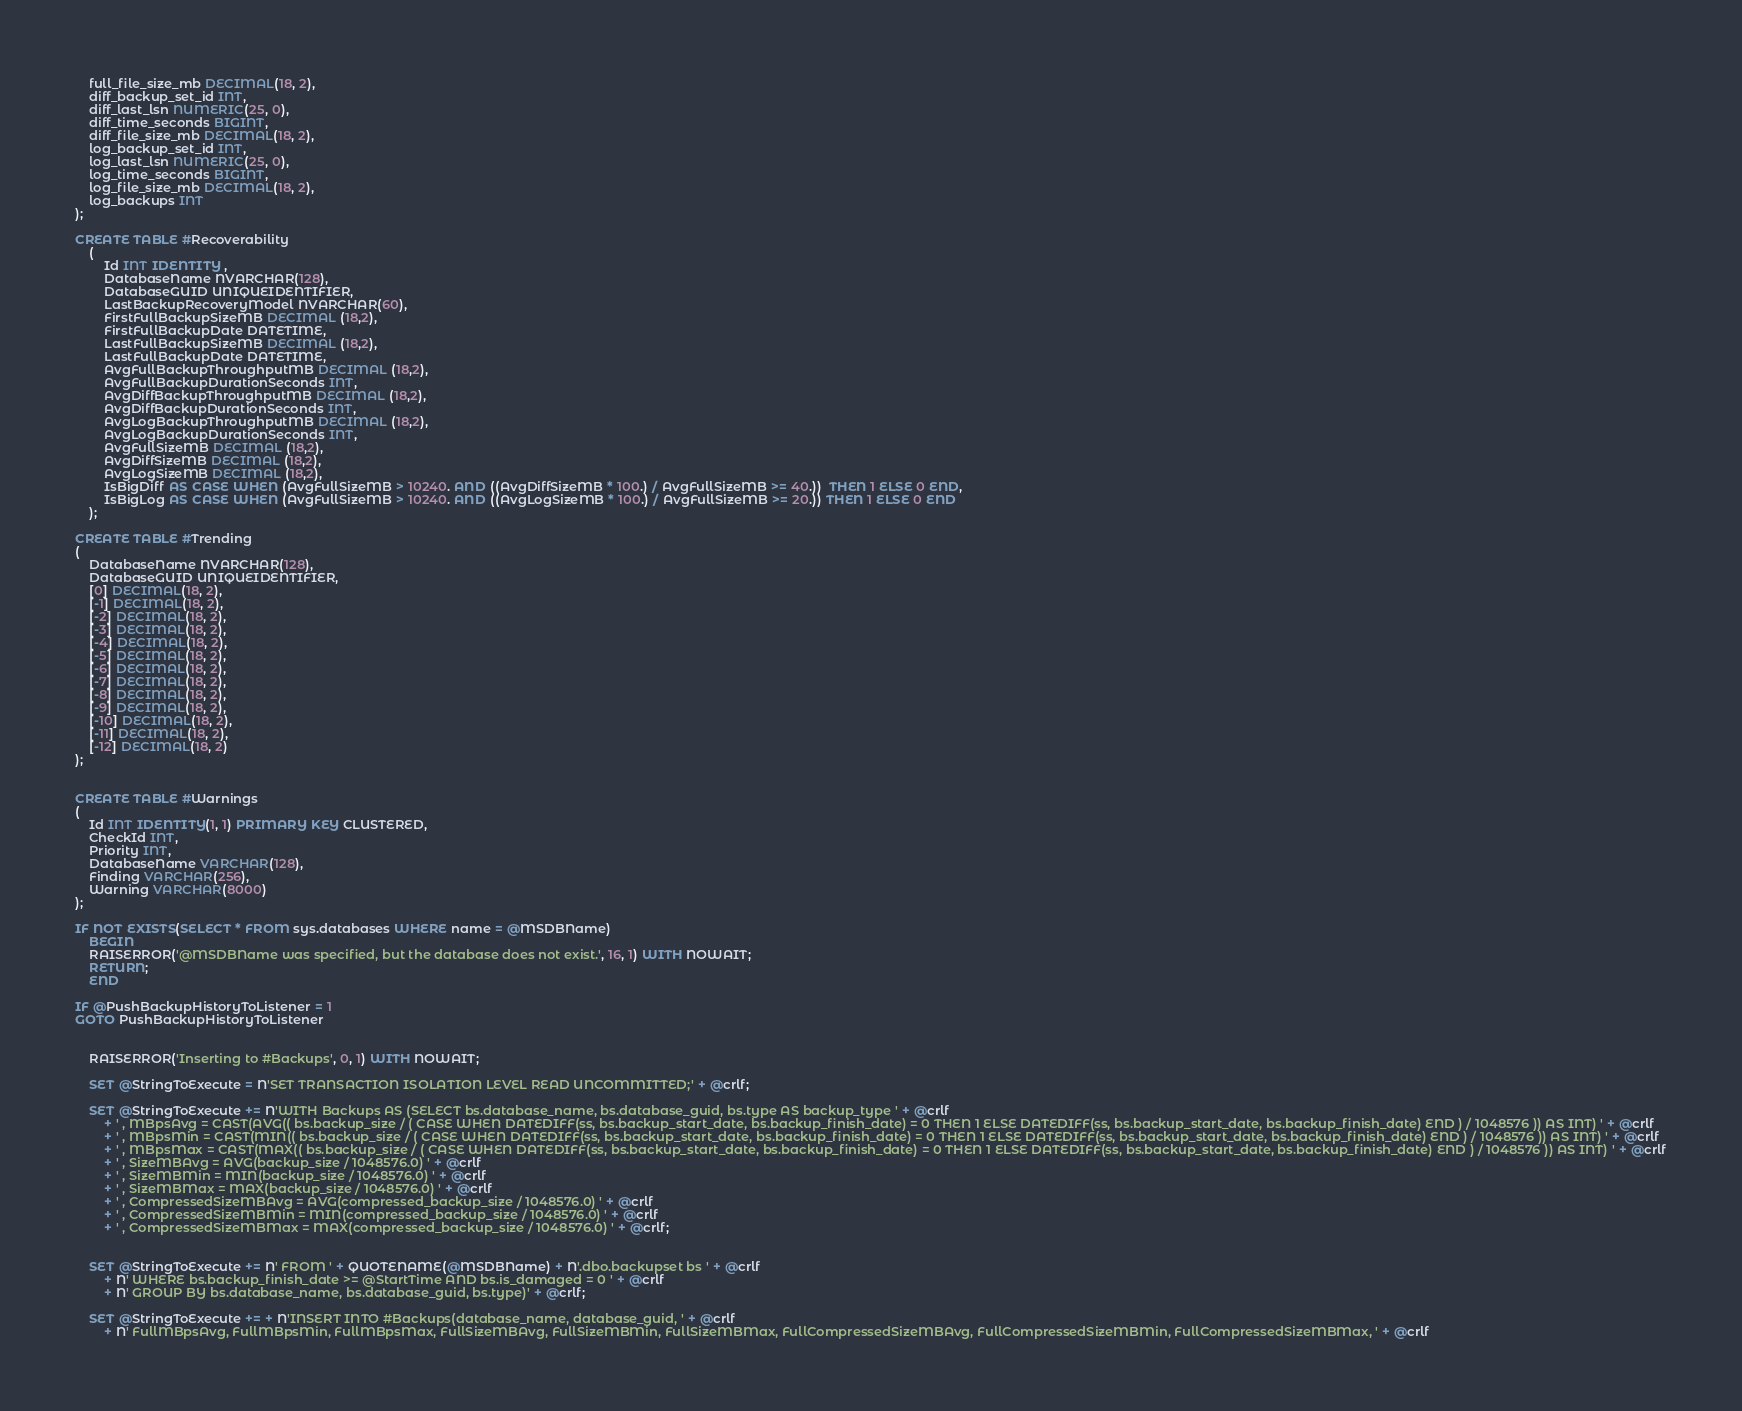<code> <loc_0><loc_0><loc_500><loc_500><_SQL_>    full_file_size_mb DECIMAL(18, 2),
    diff_backup_set_id INT,
    diff_last_lsn NUMERIC(25, 0),
    diff_time_seconds BIGINT,
    diff_file_size_mb DECIMAL(18, 2),
    log_backup_set_id INT,
    log_last_lsn NUMERIC(25, 0),
    log_time_seconds BIGINT,
    log_file_size_mb DECIMAL(18, 2),
    log_backups INT
);

CREATE TABLE #Recoverability
	(
		Id INT IDENTITY ,
		DatabaseName NVARCHAR(128),
		DatabaseGUID UNIQUEIDENTIFIER,
		LastBackupRecoveryModel NVARCHAR(60),
		FirstFullBackupSizeMB DECIMAL (18,2),
		FirstFullBackupDate DATETIME,
		LastFullBackupSizeMB DECIMAL (18,2),
		LastFullBackupDate DATETIME,
		AvgFullBackupThroughputMB DECIMAL (18,2),
		AvgFullBackupDurationSeconds INT,
		AvgDiffBackupThroughputMB DECIMAL (18,2),
		AvgDiffBackupDurationSeconds INT,
		AvgLogBackupThroughputMB DECIMAL (18,2),
		AvgLogBackupDurationSeconds INT,
		AvgFullSizeMB DECIMAL (18,2),
		AvgDiffSizeMB DECIMAL (18,2),
		AvgLogSizeMB DECIMAL (18,2),
		IsBigDiff AS CASE WHEN (AvgFullSizeMB > 10240. AND ((AvgDiffSizeMB * 100.) / AvgFullSizeMB >= 40.))  THEN 1 ELSE 0 END,
		IsBigLog AS CASE WHEN (AvgFullSizeMB > 10240. AND ((AvgLogSizeMB * 100.) / AvgFullSizeMB >= 20.)) THEN 1 ELSE 0 END
	);

CREATE TABLE #Trending
(
    DatabaseName NVARCHAR(128),
	DatabaseGUID UNIQUEIDENTIFIER,
    [0] DECIMAL(18, 2),
    [-1] DECIMAL(18, 2),
    [-2] DECIMAL(18, 2),
    [-3] DECIMAL(18, 2),
    [-4] DECIMAL(18, 2),
    [-5] DECIMAL(18, 2),
    [-6] DECIMAL(18, 2),
    [-7] DECIMAL(18, 2),
    [-8] DECIMAL(18, 2),
    [-9] DECIMAL(18, 2),
    [-10] DECIMAL(18, 2),
    [-11] DECIMAL(18, 2),
    [-12] DECIMAL(18, 2)
);


CREATE TABLE #Warnings
(
    Id INT IDENTITY(1, 1) PRIMARY KEY CLUSTERED,
    CheckId INT,
    Priority INT,
    DatabaseName VARCHAR(128),
    Finding VARCHAR(256),
    Warning VARCHAR(8000)
);

IF NOT EXISTS(SELECT * FROM sys.databases WHERE name = @MSDBName)
	BEGIN
	RAISERROR('@MSDBName was specified, but the database does not exist.', 16, 1) WITH NOWAIT;
	RETURN;
	END

IF @PushBackupHistoryToListener = 1
GOTO PushBackupHistoryToListener


	RAISERROR('Inserting to #Backups', 0, 1) WITH NOWAIT;

	SET @StringToExecute = N'SET TRANSACTION ISOLATION LEVEL READ UNCOMMITTED;' + @crlf;

	SET @StringToExecute += N'WITH Backups AS (SELECT bs.database_name, bs.database_guid, bs.type AS backup_type ' + @crlf
		+ ' , MBpsAvg = CAST(AVG(( bs.backup_size / ( CASE WHEN DATEDIFF(ss, bs.backup_start_date, bs.backup_finish_date) = 0 THEN 1 ELSE DATEDIFF(ss, bs.backup_start_date, bs.backup_finish_date) END ) / 1048576 )) AS INT) ' + @crlf
		+ ' , MBpsMin = CAST(MIN(( bs.backup_size / ( CASE WHEN DATEDIFF(ss, bs.backup_start_date, bs.backup_finish_date) = 0 THEN 1 ELSE DATEDIFF(ss, bs.backup_start_date, bs.backup_finish_date) END ) / 1048576 )) AS INT) ' + @crlf
		+ ' , MBpsMax = CAST(MAX(( bs.backup_size / ( CASE WHEN DATEDIFF(ss, bs.backup_start_date, bs.backup_finish_date) = 0 THEN 1 ELSE DATEDIFF(ss, bs.backup_start_date, bs.backup_finish_date) END ) / 1048576 )) AS INT) ' + @crlf
		+ ' , SizeMBAvg = AVG(backup_size / 1048576.0) ' + @crlf
		+ ' , SizeMBMin = MIN(backup_size / 1048576.0) ' + @crlf
		+ ' , SizeMBMax = MAX(backup_size / 1048576.0) ' + @crlf
		+ ' , CompressedSizeMBAvg = AVG(compressed_backup_size / 1048576.0) ' + @crlf
		+ ' , CompressedSizeMBMin = MIN(compressed_backup_size / 1048576.0) ' + @crlf
		+ ' , CompressedSizeMBMax = MAX(compressed_backup_size / 1048576.0) ' + @crlf;


	SET @StringToExecute += N' FROM ' + QUOTENAME(@MSDBName) + N'.dbo.backupset bs ' + @crlf
		+ N' WHERE bs.backup_finish_date >= @StartTime AND bs.is_damaged = 0 ' + @crlf
		+ N' GROUP BY bs.database_name, bs.database_guid, bs.type)' + @crlf;

	SET @StringToExecute += + N'INSERT INTO #Backups(database_name, database_guid, ' + @crlf
		+ N' FullMBpsAvg, FullMBpsMin, FullMBpsMax, FullSizeMBAvg, FullSizeMBMin, FullSizeMBMax, FullCompressedSizeMBAvg, FullCompressedSizeMBMin, FullCompressedSizeMBMax, ' + @crlf</code> 